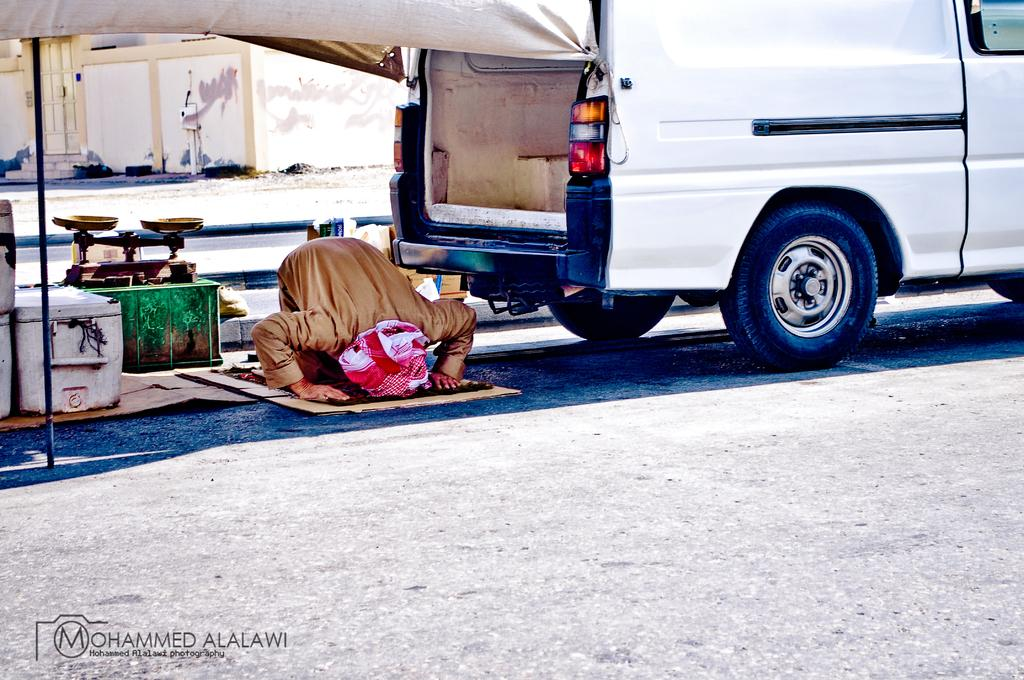What is the main subject in the center of the image? There is a vehicle and a person in the center of the image. What can be seen on the road in the center of the image? There are objects on the road in the center of the image. What is visible in the background of the image? There is a building and a road visible in the background of the image. What type of skirt is the vehicle wearing in the image? There is no skirt present in the image, as vehicles do not wear clothing. What direction is the person walking in the image? The image does not show the person walking; they are in the center of the image with the vehicle. 